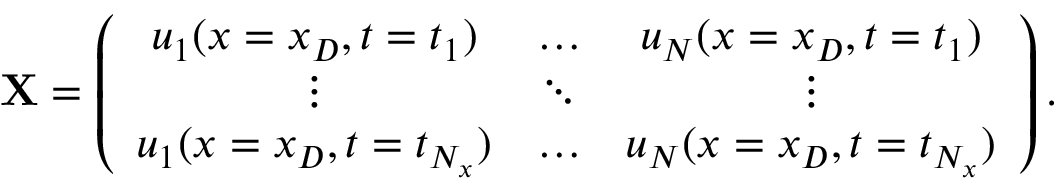<formula> <loc_0><loc_0><loc_500><loc_500>X = \left ( \begin{array} { c c c } { u _ { 1 } ( x = x _ { D } , t = t _ { 1 } ) } & { \dots } & { u _ { N } ( x = x _ { D } , t = t _ { 1 } ) } \\ { \vdots } & { \ddots } & { \vdots } \\ { u _ { 1 } ( x = x _ { D } , t = t _ { N _ { x } } ) } & { \dots } & { u _ { N } ( x = x _ { D } , t = t _ { N _ { x } } ) } \end{array} \right ) .</formula> 